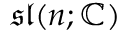<formula> <loc_0><loc_0><loc_500><loc_500>{ \mathfrak { s l } } ( n ; \mathbb { C } )</formula> 